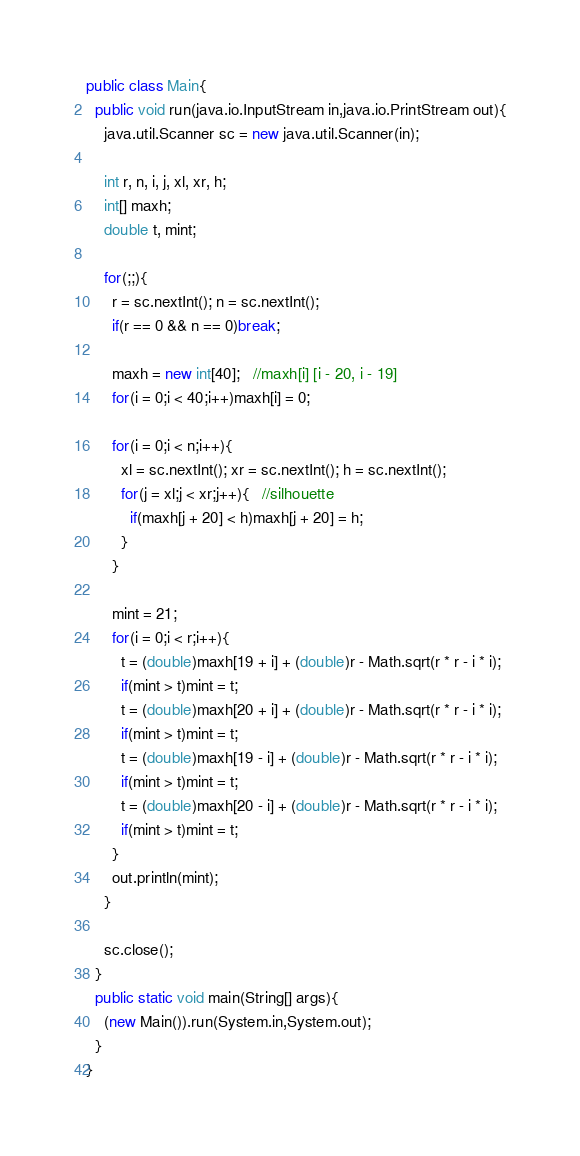Convert code to text. <code><loc_0><loc_0><loc_500><loc_500><_Java_>public class Main{
  public void run(java.io.InputStream in,java.io.PrintStream out){
    java.util.Scanner sc = new java.util.Scanner(in);

    int r, n, i, j, xl, xr, h;
    int[] maxh;
    double t, mint;

    for(;;){
      r = sc.nextInt(); n = sc.nextInt();
      if(r == 0 && n == 0)break;

      maxh = new int[40];   //maxh[i] [i - 20, i - 19]
      for(i = 0;i < 40;i++)maxh[i] = 0;

      for(i = 0;i < n;i++){
        xl = sc.nextInt(); xr = sc.nextInt(); h = sc.nextInt();
        for(j = xl;j < xr;j++){   //silhouette
          if(maxh[j + 20] < h)maxh[j + 20] = h;
        }
      }

      mint = 21;
      for(i = 0;i < r;i++){
        t = (double)maxh[19 + i] + (double)r - Math.sqrt(r * r - i * i);
        if(mint > t)mint = t;
        t = (double)maxh[20 + i] + (double)r - Math.sqrt(r * r - i * i);
        if(mint > t)mint = t;
        t = (double)maxh[19 - i] + (double)r - Math.sqrt(r * r - i * i);
        if(mint > t)mint = t;
        t = (double)maxh[20 - i] + (double)r - Math.sqrt(r * r - i * i);
        if(mint > t)mint = t;
      }
      out.println(mint);
    }

    sc.close();
  }
  public static void main(String[] args){
    (new Main()).run(System.in,System.out);
  }
}</code> 